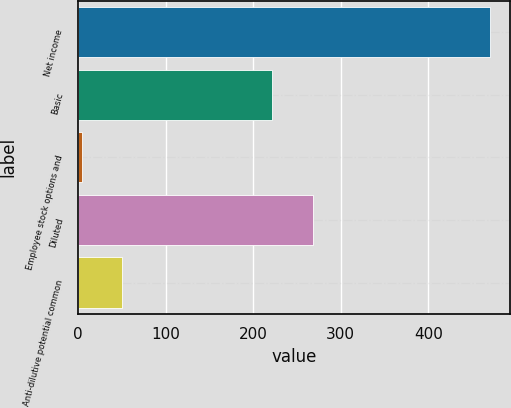Convert chart to OTSL. <chart><loc_0><loc_0><loc_500><loc_500><bar_chart><fcel>Net income<fcel>Basic<fcel>Employee stock options and<fcel>Diluted<fcel>Anti-dilutive potential common<nl><fcel>470<fcel>222<fcel>4<fcel>268.6<fcel>50.6<nl></chart> 